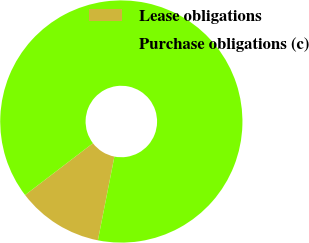<chart> <loc_0><loc_0><loc_500><loc_500><pie_chart><fcel>Lease obligations<fcel>Purchase obligations (c)<nl><fcel>11.52%<fcel>88.48%<nl></chart> 